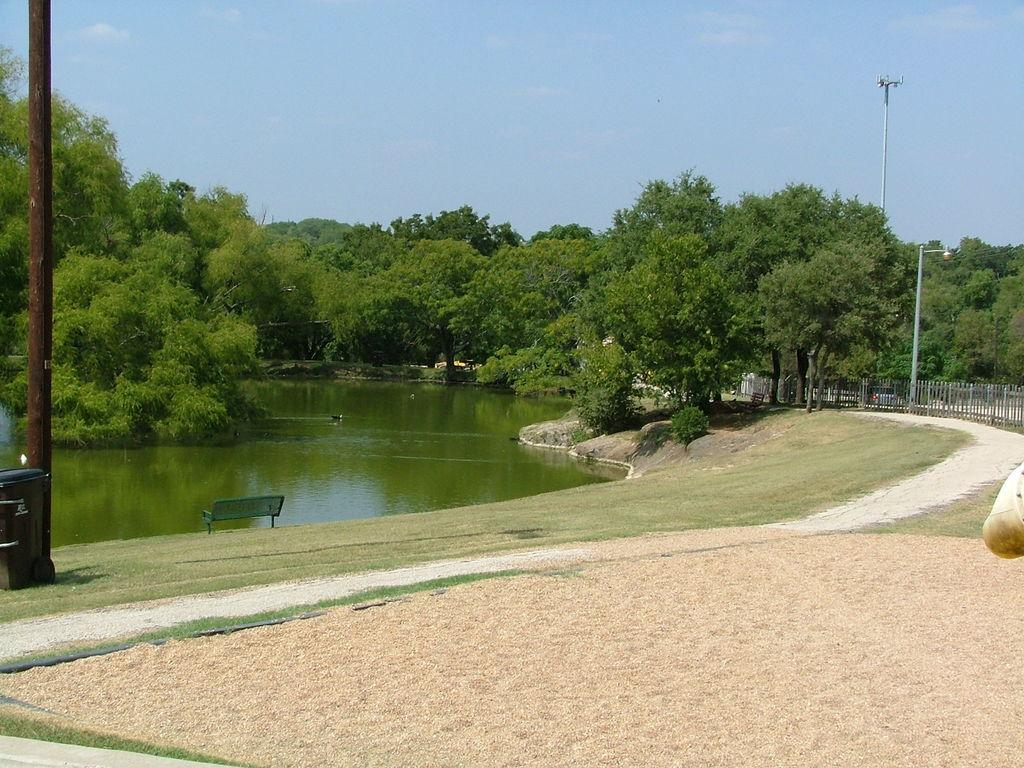What is located on the ground in the image? There is a bench on the ground in the image. What object is present for disposing of waste? There is a dustbin in the image. What structures can be seen in the image? There are poles and a fence in the image. What type of vegetation is present in the image? There are trees in the image. What natural element is visible in the image? There is water visible in the image. What can be seen in the background of the image? The sky with clouds is visible in the background of the image. How many spiders are crawling on the bench in the image? There are no spiders visible on the bench in the image. What type of cub is playing near the water in the image? There is no cub present in the image; it features a bench, dustbin, poles, trees, water, a fence, and a sky with clouds. 